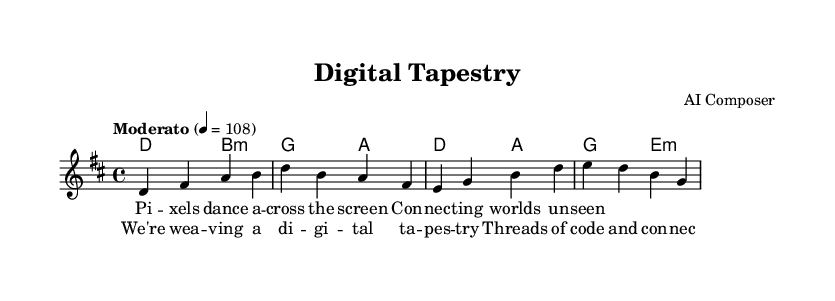What is the key signature of this music? The key signature of the music is indicated by the presence of two sharps, which is characteristic of the D major key.
Answer: D major What is the time signature of this piece? The time signature is represented by the numbers at the beginning of the sheet music, which shows four beats in each measure. This is denoted as 4/4.
Answer: 4/4 What is the tempo marking for this piece? The tempo marking is noted at the beginning of the music, indicating a moderato pace, which specifies that it should be played at a moderate speed. The exact value given is 108 beats per minute.
Answer: Moderato How many measures are in the melody section? The melody section consists of four measures, as indicated by the arrangement of the notes grouped into four distinct segments.
Answer: Four What are the lyrics of the chorus? The chorus lyrics are displayed below the melody, showing the words that correspond with the melody during the chorus section. They speak to themes of digital connectivity and innovation.
Answer: We're weaving a digital tapestry Which chords are used in the first harmonic progression? The first harmonic progression is defined by observing the chord symbols above the staff. The initial chords played are D major and B minor.
Answer: D major and B minor 